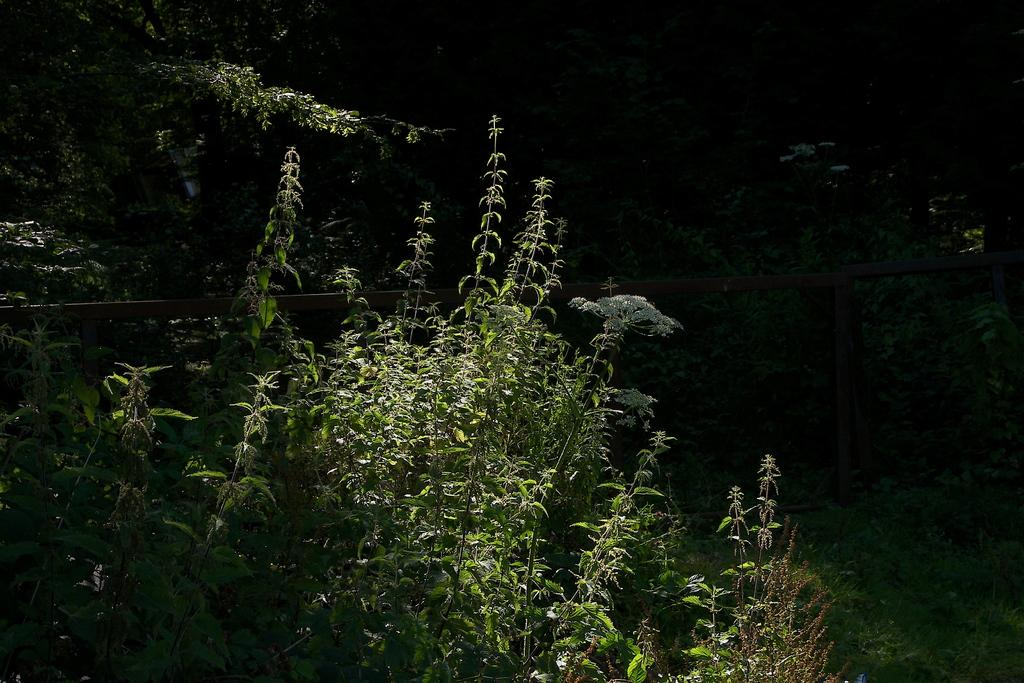What type of natural elements can be seen in the image? There are trees in the image. What type of structure is present in the image? There is railing in the image. How many visitors can be seen interacting with the aunt in the image? There are no visitors or aunts present in the image; it only features trees and railing. 